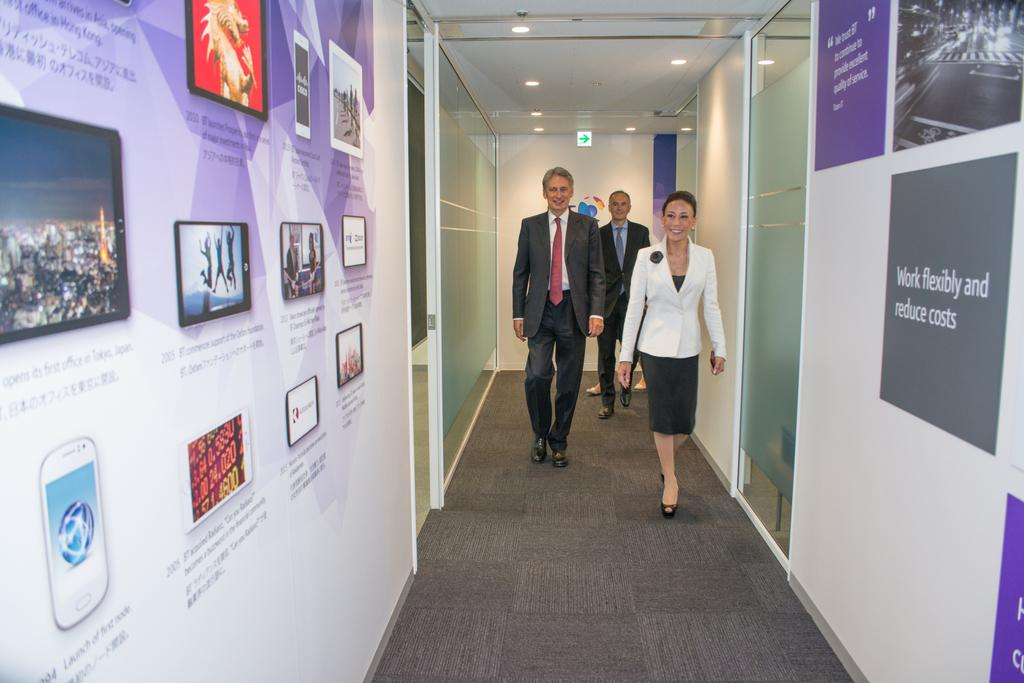<image>
Render a clear and concise summary of the photo. A sign in a hallways says "work flexibly and reduce costs." 